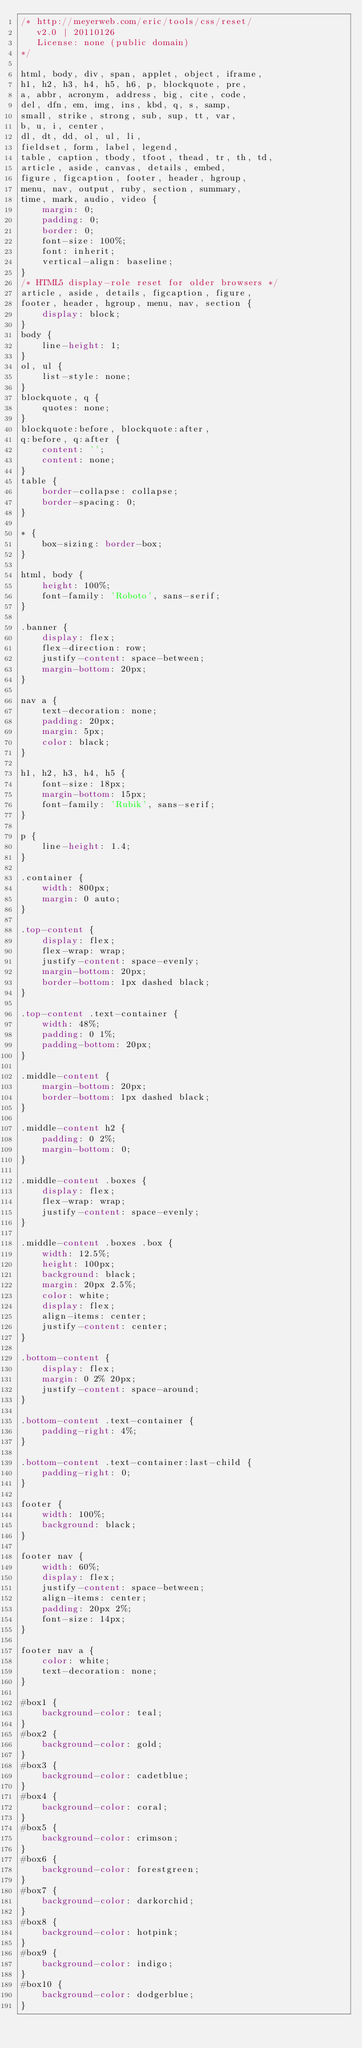<code> <loc_0><loc_0><loc_500><loc_500><_CSS_>/* http://meyerweb.com/eric/tools/css/reset/ 
   v2.0 | 20110126
   License: none (public domain)
*/

html, body, div, span, applet, object, iframe,
h1, h2, h3, h4, h5, h6, p, blockquote, pre,
a, abbr, acronym, address, big, cite, code,
del, dfn, em, img, ins, kbd, q, s, samp,
small, strike, strong, sub, sup, tt, var,
b, u, i, center,
dl, dt, dd, ol, ul, li,
fieldset, form, label, legend,
table, caption, tbody, tfoot, thead, tr, th, td,
article, aside, canvas, details, embed, 
figure, figcaption, footer, header, hgroup, 
menu, nav, output, ruby, section, summary,
time, mark, audio, video {
	margin: 0;
	padding: 0;
	border: 0;
	font-size: 100%;
	font: inherit;
	vertical-align: baseline;
}
/* HTML5 display-role reset for older browsers */
article, aside, details, figcaption, figure, 
footer, header, hgroup, menu, nav, section {
	display: block;
}
body {
	line-height: 1;
}
ol, ul {
	list-style: none;
}
blockquote, q {
	quotes: none;
}
blockquote:before, blockquote:after,
q:before, q:after {
	content: '';
	content: none;
}
table {
	border-collapse: collapse;
	border-spacing: 0;
}

* {
    box-sizing: border-box;
}

html, body {
    height: 100%;
    font-family: 'Roboto', sans-serif;
}

.banner {
    display: flex;
    flex-direction: row;
    justify-content: space-between;
    margin-bottom: 20px;
}

nav a {
    text-decoration: none;
    padding: 20px;
    margin: 5px;
    color: black;   
}

h1, h2, h3, h4, h5 {
    font-size: 18px;
    margin-bottom: 15px;
    font-family: 'Rubik', sans-serif;
}

p {
    line-height: 1.4;
}

.container {
    width: 800px;
    margin: 0 auto;
}

.top-content {
    display: flex;
    flex-wrap: wrap;
    justify-content: space-evenly;
    margin-bottom: 20px;
    border-bottom: 1px dashed black;
}

.top-content .text-container {
    width: 48%;
    padding: 0 1%;
    padding-bottom: 20px;  
}

.middle-content {
    margin-bottom: 20px;
    border-bottom: 1px dashed black;
}

.middle-content h2 {
    padding: 0 2%;
    margin-bottom: 0;
}

.middle-content .boxes {
    display: flex;
    flex-wrap: wrap;
    justify-content: space-evenly;
}

.middle-content .boxes .box {
    width: 12.5%;
    height: 100px;
    background: black;
    margin: 20px 2.5%;
    color: white;
    display: flex;
    align-items: center;
    justify-content: center;
}

.bottom-content {
    display: flex;
    margin: 0 2% 20px;
    justify-content: space-around;
}

.bottom-content .text-container {
    padding-right: 4%;
}

.bottom-content .text-container:last-child {
    padding-right: 0;
}

footer {
    width: 100%;
    background: black;
}

footer nav {
    width: 60%;
    display: flex;
    justify-content: space-between;
    align-items: center;
    padding: 20px 2%;
    font-size: 14px;
}

footer nav a {
    color: white;
    text-decoration: none;
}

#box1 {
    background-color: teal;
}
#box2 {
    background-color: gold;
}
#box3 {
    background-color: cadetblue;
}
#box4 {
    background-color: coral;
}
#box5 {
    background-color: crimson;
}
#box6 {
    background-color: forestgreen;
}
#box7 {
    background-color: darkorchid;
}
#box8 {
    background-color: hotpink;
}
#box9 {
    background-color: indigo;
}
#box10 {
    background-color: dodgerblue;
}</code> 